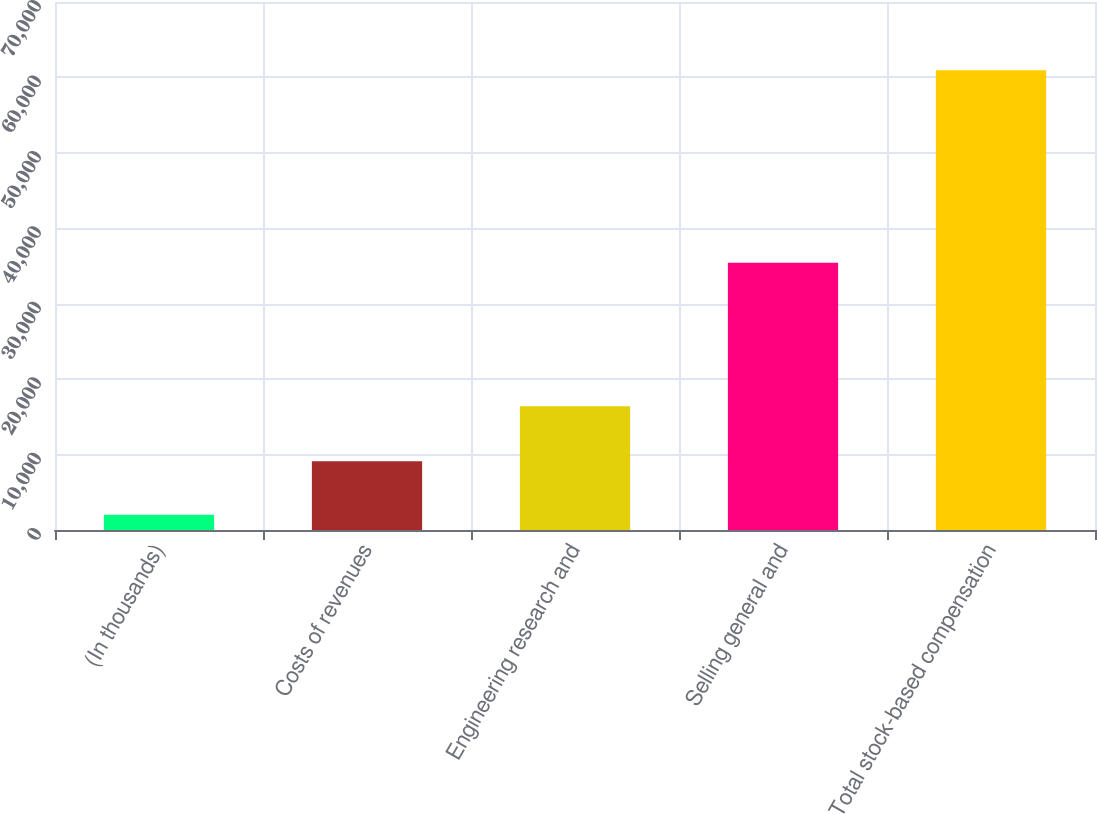<chart> <loc_0><loc_0><loc_500><loc_500><bar_chart><fcel>(In thousands)<fcel>Costs of revenues<fcel>Engineering research and<fcel>Selling general and<fcel>Total stock-based compensation<nl><fcel>2014<fcel>9101<fcel>16397<fcel>35442<fcel>60940<nl></chart> 